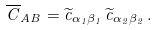Convert formula to latex. <formula><loc_0><loc_0><loc_500><loc_500>\overline { C } _ { A B } = \widetilde { c } _ { \alpha _ { 1 } \beta _ { 1 } } \, \widetilde { c } _ { \alpha _ { 2 } \beta _ { 2 } } \, .</formula> 